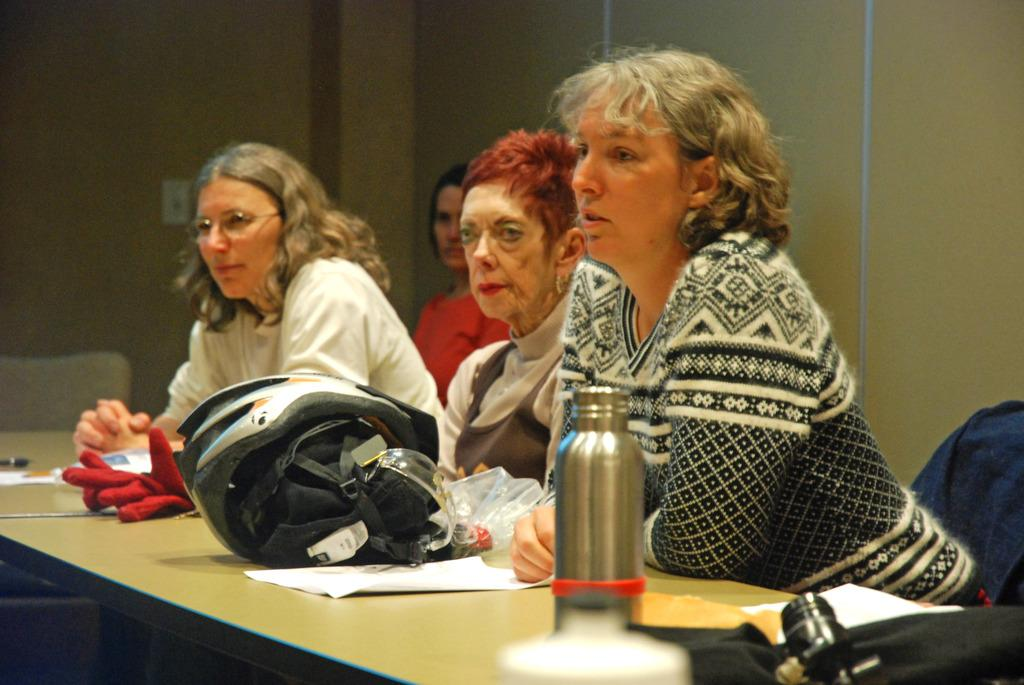How many women are present in the image? There are four women in the image. What are the women doing in the image? The women are sitting on chairs. What is located in front of the women? There is a table in front of the women. What objects can be seen on the table? There is a bottle, a helmet, and papers on the table. What is visible in the background of the image? There is a wall in the background of the image. Which direction are the women facing in the image? The provided facts do not mention the direction the women are facing, so it cannot be determined from the image. Are there any mice present in the image? There are no mice present in the image. 